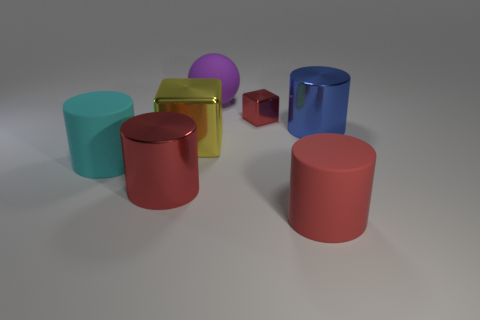There is a small cube; is its color the same as the rubber cylinder right of the large ball?
Your answer should be compact. Yes. There is a large matte cylinder to the right of the tiny thing that is to the right of the matte sphere; what is its color?
Keep it short and to the point. Red. Is there any other thing that is the same size as the red metal cube?
Provide a succinct answer. No. There is a big red object on the right side of the big purple rubber sphere; is it the same shape as the large red shiny object?
Offer a terse response. Yes. How many big objects are in front of the small red thing and on the left side of the red matte thing?
Your answer should be very brief. 3. The large cylinder behind the big object that is left of the shiny cylinder that is left of the blue metal cylinder is what color?
Offer a terse response. Blue. What number of red blocks are in front of the tiny red metallic object that is right of the big red metal cylinder?
Ensure brevity in your answer.  0. What number of other things are the same shape as the large yellow metallic thing?
Keep it short and to the point. 1. How many things are either tiny red cubes or large things in front of the blue object?
Offer a very short reply. 5. Is the number of big metallic cylinders that are on the right side of the red block greater than the number of big yellow objects that are in front of the cyan thing?
Ensure brevity in your answer.  Yes. 